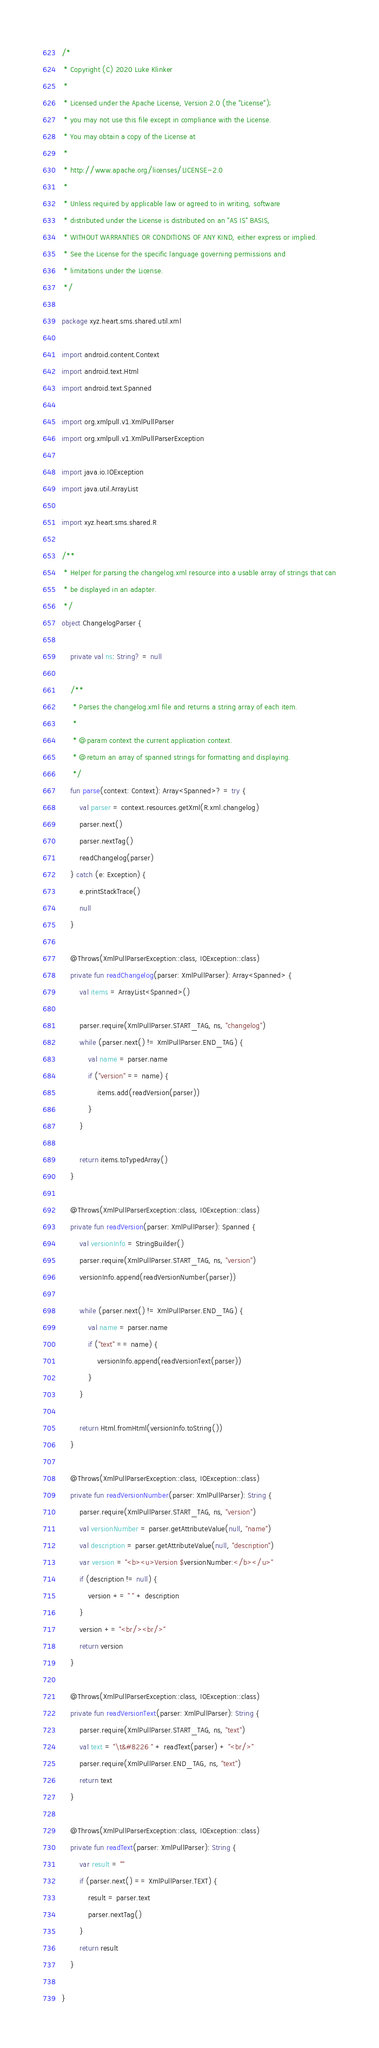<code> <loc_0><loc_0><loc_500><loc_500><_Kotlin_>/*
 * Copyright (C) 2020 Luke Klinker
 *
 * Licensed under the Apache License, Version 2.0 (the "License");
 * you may not use this file except in compliance with the License.
 * You may obtain a copy of the License at
 *
 * http://www.apache.org/licenses/LICENSE-2.0
 *
 * Unless required by applicable law or agreed to in writing, software
 * distributed under the License is distributed on an "AS IS" BASIS,
 * WITHOUT WARRANTIES OR CONDITIONS OF ANY KIND, either express or implied.
 * See the License for the specific language governing permissions and
 * limitations under the License.
 */

package xyz.heart.sms.shared.util.xml

import android.content.Context
import android.text.Html
import android.text.Spanned

import org.xmlpull.v1.XmlPullParser
import org.xmlpull.v1.XmlPullParserException

import java.io.IOException
import java.util.ArrayList

import xyz.heart.sms.shared.R

/**
 * Helper for parsing the changelog.xml resource into a usable array of strings that can
 * be displayed in an adapter.
 */
object ChangelogParser {

    private val ns: String? = null

    /**
     * Parses the changelog.xml file and returns a string array of each item.
     *
     * @param context the current application context.
     * @return an array of spanned strings for formatting and displaying.
     */
    fun parse(context: Context): Array<Spanned>? = try {
        val parser = context.resources.getXml(R.xml.changelog)
        parser.next()
        parser.nextTag()
        readChangelog(parser)
    } catch (e: Exception) {
        e.printStackTrace()
        null
    }

    @Throws(XmlPullParserException::class, IOException::class)
    private fun readChangelog(parser: XmlPullParser): Array<Spanned> {
        val items = ArrayList<Spanned>()

        parser.require(XmlPullParser.START_TAG, ns, "changelog")
        while (parser.next() != XmlPullParser.END_TAG) {
            val name = parser.name
            if ("version" == name) {
                items.add(readVersion(parser))
            }
        }

        return items.toTypedArray()
    }

    @Throws(XmlPullParserException::class, IOException::class)
    private fun readVersion(parser: XmlPullParser): Spanned {
        val versionInfo = StringBuilder()
        parser.require(XmlPullParser.START_TAG, ns, "version")
        versionInfo.append(readVersionNumber(parser))

        while (parser.next() != XmlPullParser.END_TAG) {
            val name = parser.name
            if ("text" == name) {
                versionInfo.append(readVersionText(parser))
            }
        }

        return Html.fromHtml(versionInfo.toString())
    }

    @Throws(XmlPullParserException::class, IOException::class)
    private fun readVersionNumber(parser: XmlPullParser): String {
        parser.require(XmlPullParser.START_TAG, ns, "version")
        val versionNumber = parser.getAttributeValue(null, "name")
        val description = parser.getAttributeValue(null, "description")
        var version = "<b><u>Version $versionNumber:</b></u>"
        if (description != null) {
            version += " " + description
        }
        version += "<br/><br/>"
        return version
    }

    @Throws(XmlPullParserException::class, IOException::class)
    private fun readVersionText(parser: XmlPullParser): String {
        parser.require(XmlPullParser.START_TAG, ns, "text")
        val text = "\t&#8226 " + readText(parser) + "<br/>"
        parser.require(XmlPullParser.END_TAG, ns, "text")
        return text
    }

    @Throws(XmlPullParserException::class, IOException::class)
    private fun readText(parser: XmlPullParser): String {
        var result = ""
        if (parser.next() == XmlPullParser.TEXT) {
            result = parser.text
            parser.nextTag()
        }
        return result
    }

}</code> 